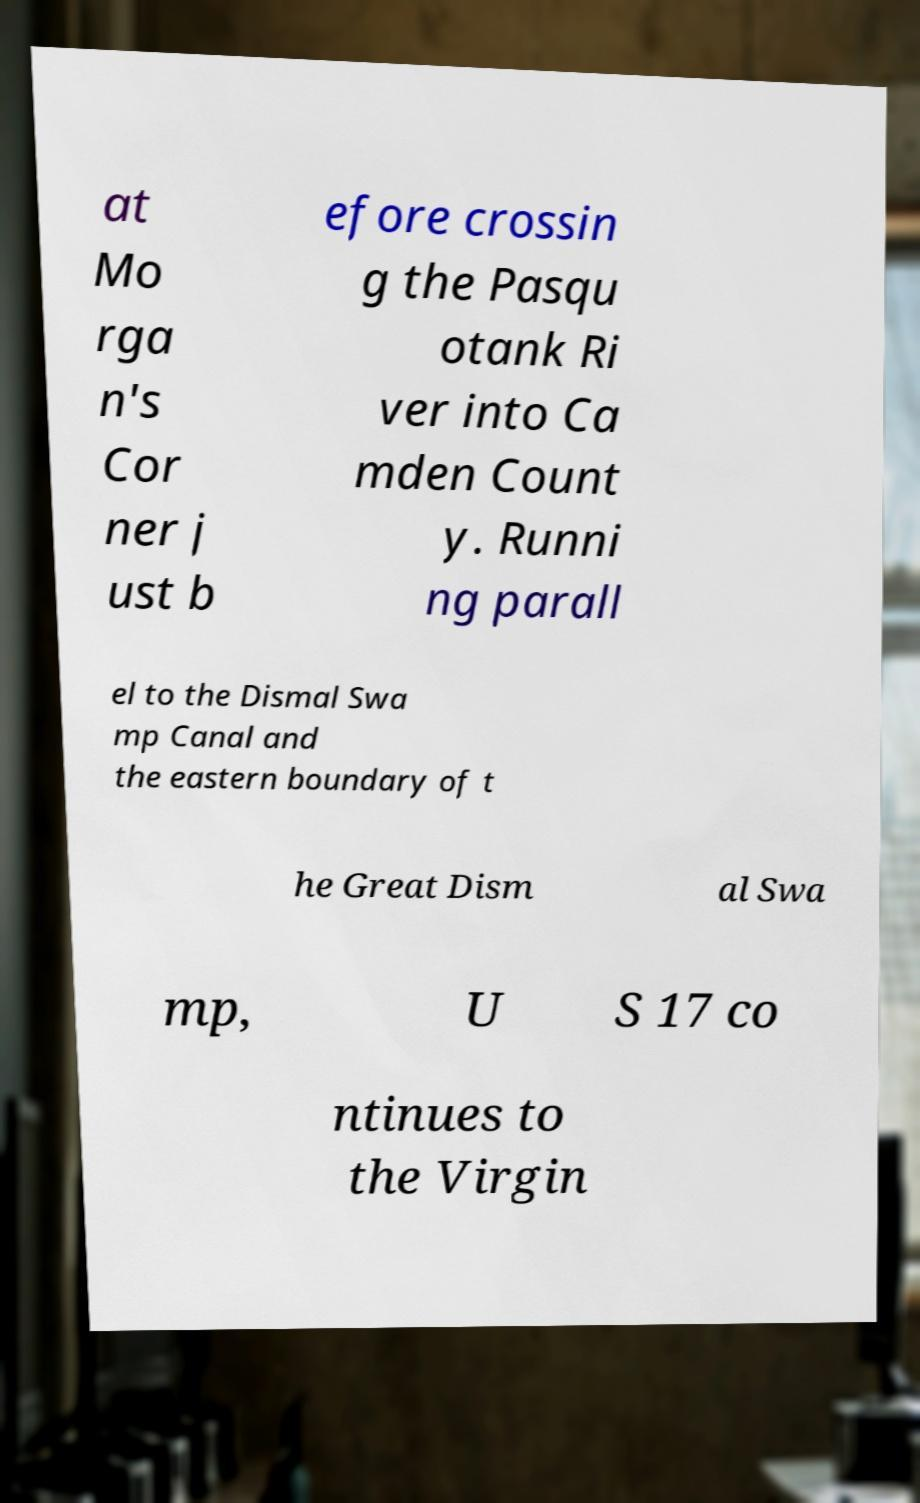Could you extract and type out the text from this image? at Mo rga n's Cor ner j ust b efore crossin g the Pasqu otank Ri ver into Ca mden Count y. Runni ng parall el to the Dismal Swa mp Canal and the eastern boundary of t he Great Dism al Swa mp, U S 17 co ntinues to the Virgin 